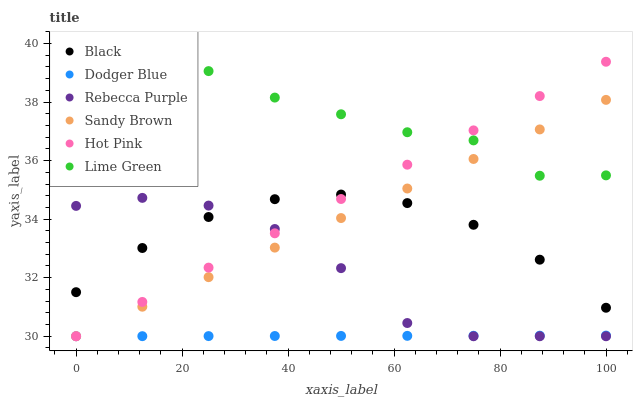Does Dodger Blue have the minimum area under the curve?
Answer yes or no. Yes. Does Lime Green have the maximum area under the curve?
Answer yes or no. Yes. Does Hot Pink have the minimum area under the curve?
Answer yes or no. No. Does Hot Pink have the maximum area under the curve?
Answer yes or no. No. Is Sandy Brown the smoothest?
Answer yes or no. Yes. Is Rebecca Purple the roughest?
Answer yes or no. Yes. Is Hot Pink the smoothest?
Answer yes or no. No. Is Hot Pink the roughest?
Answer yes or no. No. Does Sandy Brown have the lowest value?
Answer yes or no. Yes. Does Black have the lowest value?
Answer yes or no. No. Does Lime Green have the highest value?
Answer yes or no. Yes. Does Hot Pink have the highest value?
Answer yes or no. No. Is Rebecca Purple less than Lime Green?
Answer yes or no. Yes. Is Lime Green greater than Rebecca Purple?
Answer yes or no. Yes. Does Dodger Blue intersect Rebecca Purple?
Answer yes or no. Yes. Is Dodger Blue less than Rebecca Purple?
Answer yes or no. No. Is Dodger Blue greater than Rebecca Purple?
Answer yes or no. No. Does Rebecca Purple intersect Lime Green?
Answer yes or no. No. 